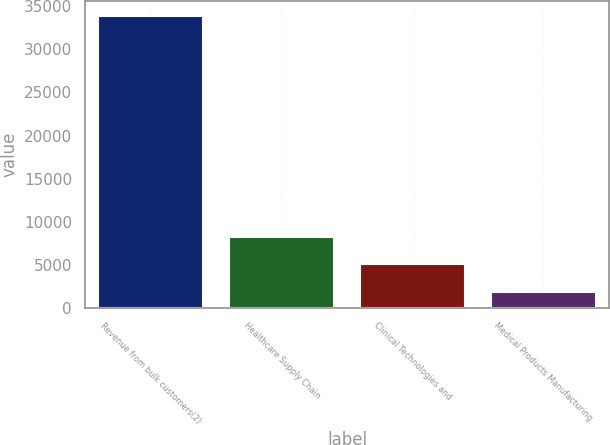Convert chart to OTSL. <chart><loc_0><loc_0><loc_500><loc_500><bar_chart><fcel>Revenue from bulk customers(2)<fcel>Healthcare Supply Chain<fcel>Clinical Technologies and<fcel>Medical Products Manufacturing<nl><fcel>33900<fcel>8248.72<fcel>5042.31<fcel>1835.9<nl></chart> 